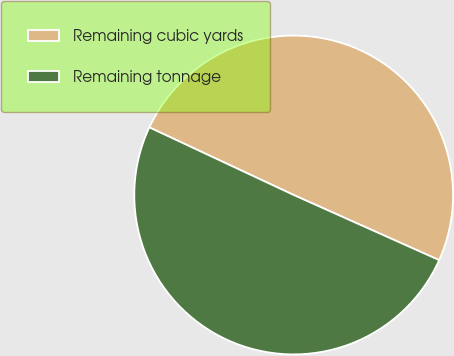Convert chart to OTSL. <chart><loc_0><loc_0><loc_500><loc_500><pie_chart><fcel>Remaining cubic yards<fcel>Remaining tonnage<nl><fcel>49.73%<fcel>50.27%<nl></chart> 